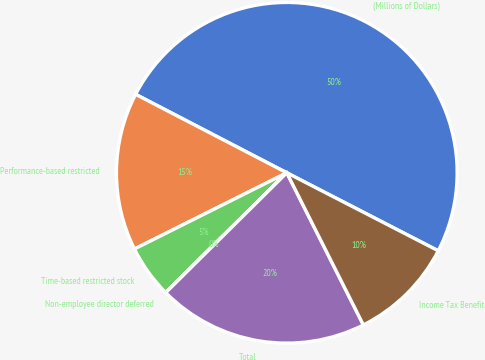Convert chart to OTSL. <chart><loc_0><loc_0><loc_500><loc_500><pie_chart><fcel>(Millions of Dollars)<fcel>Performance-based restricted<fcel>Time-based restricted stock<fcel>Non-employee director deferred<fcel>Total<fcel>Income Tax Benefit<nl><fcel>49.95%<fcel>15.0%<fcel>5.02%<fcel>0.02%<fcel>20.0%<fcel>10.01%<nl></chart> 